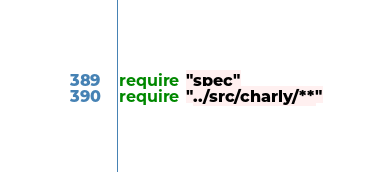<code> <loc_0><loc_0><loc_500><loc_500><_Crystal_>require "spec"
require "../src/charly/**"
</code> 